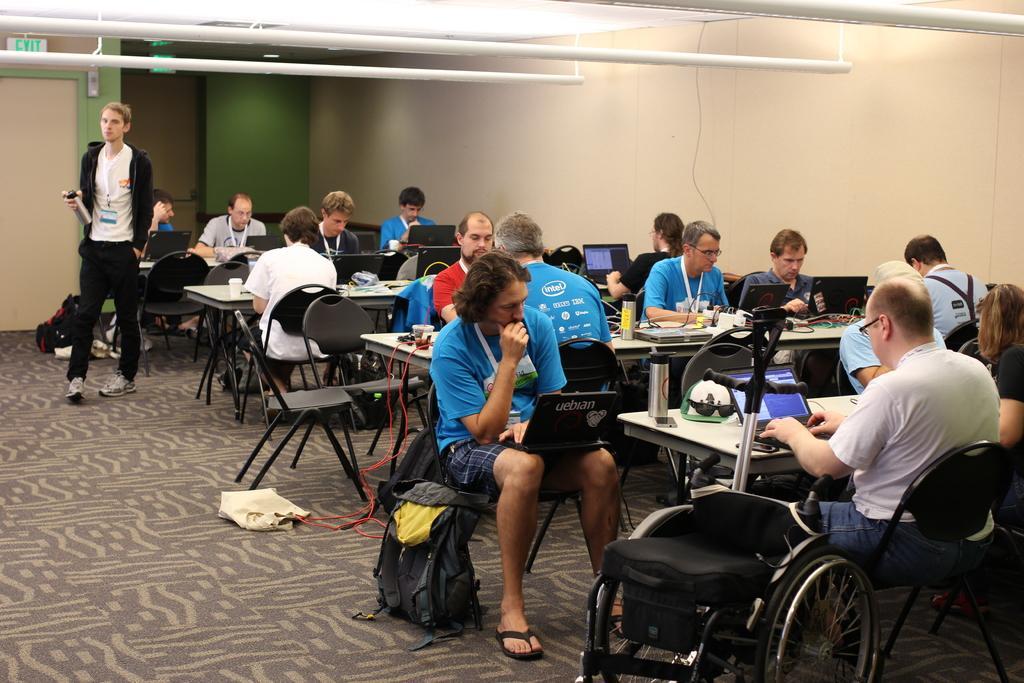In one or two sentences, can you explain what this image depicts? In this picture I can see a group of people are sitting on the chairs and working with their laptops, on the left side a man is walking and I can see the door and an exit board. 